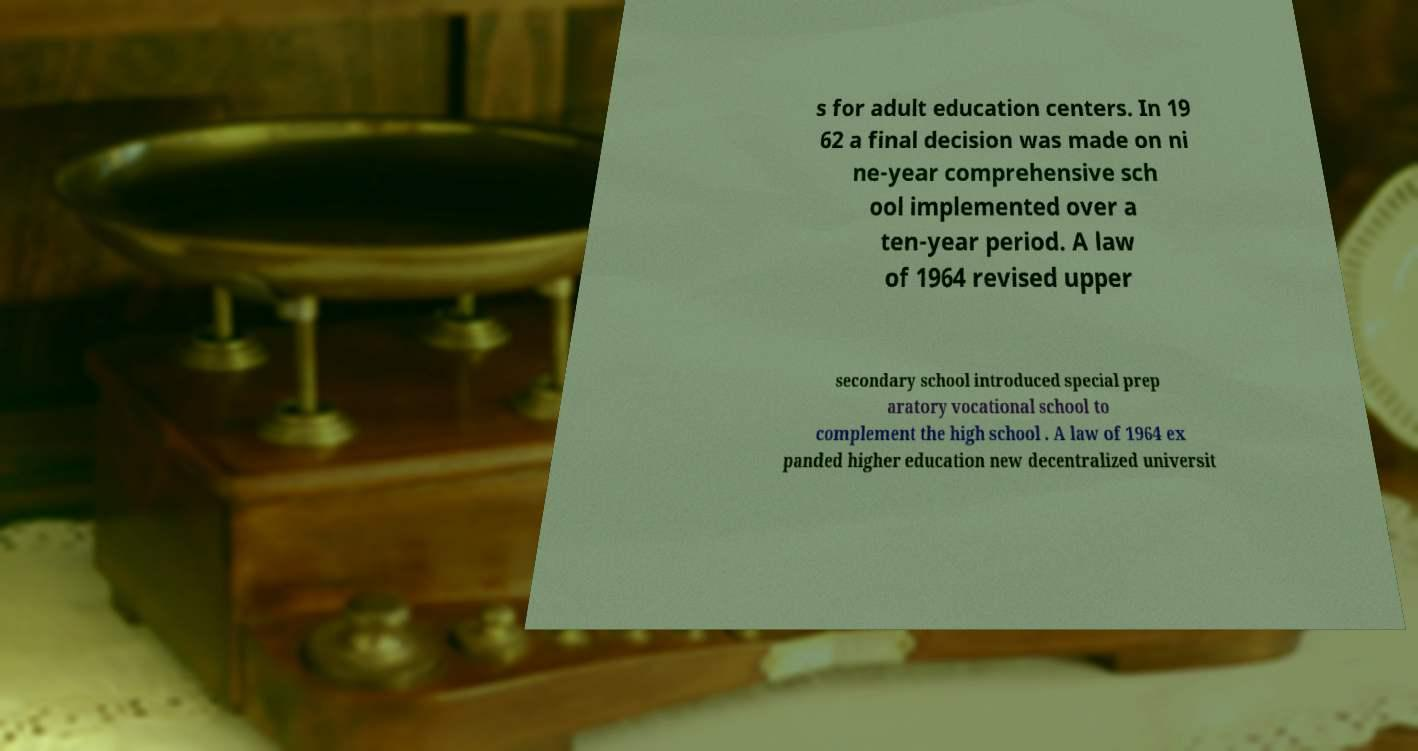Please identify and transcribe the text found in this image. s for adult education centers. In 19 62 a final decision was made on ni ne-year comprehensive sch ool implemented over a ten-year period. A law of 1964 revised upper secondary school introduced special prep aratory vocational school to complement the high school . A law of 1964 ex panded higher education new decentralized universit 